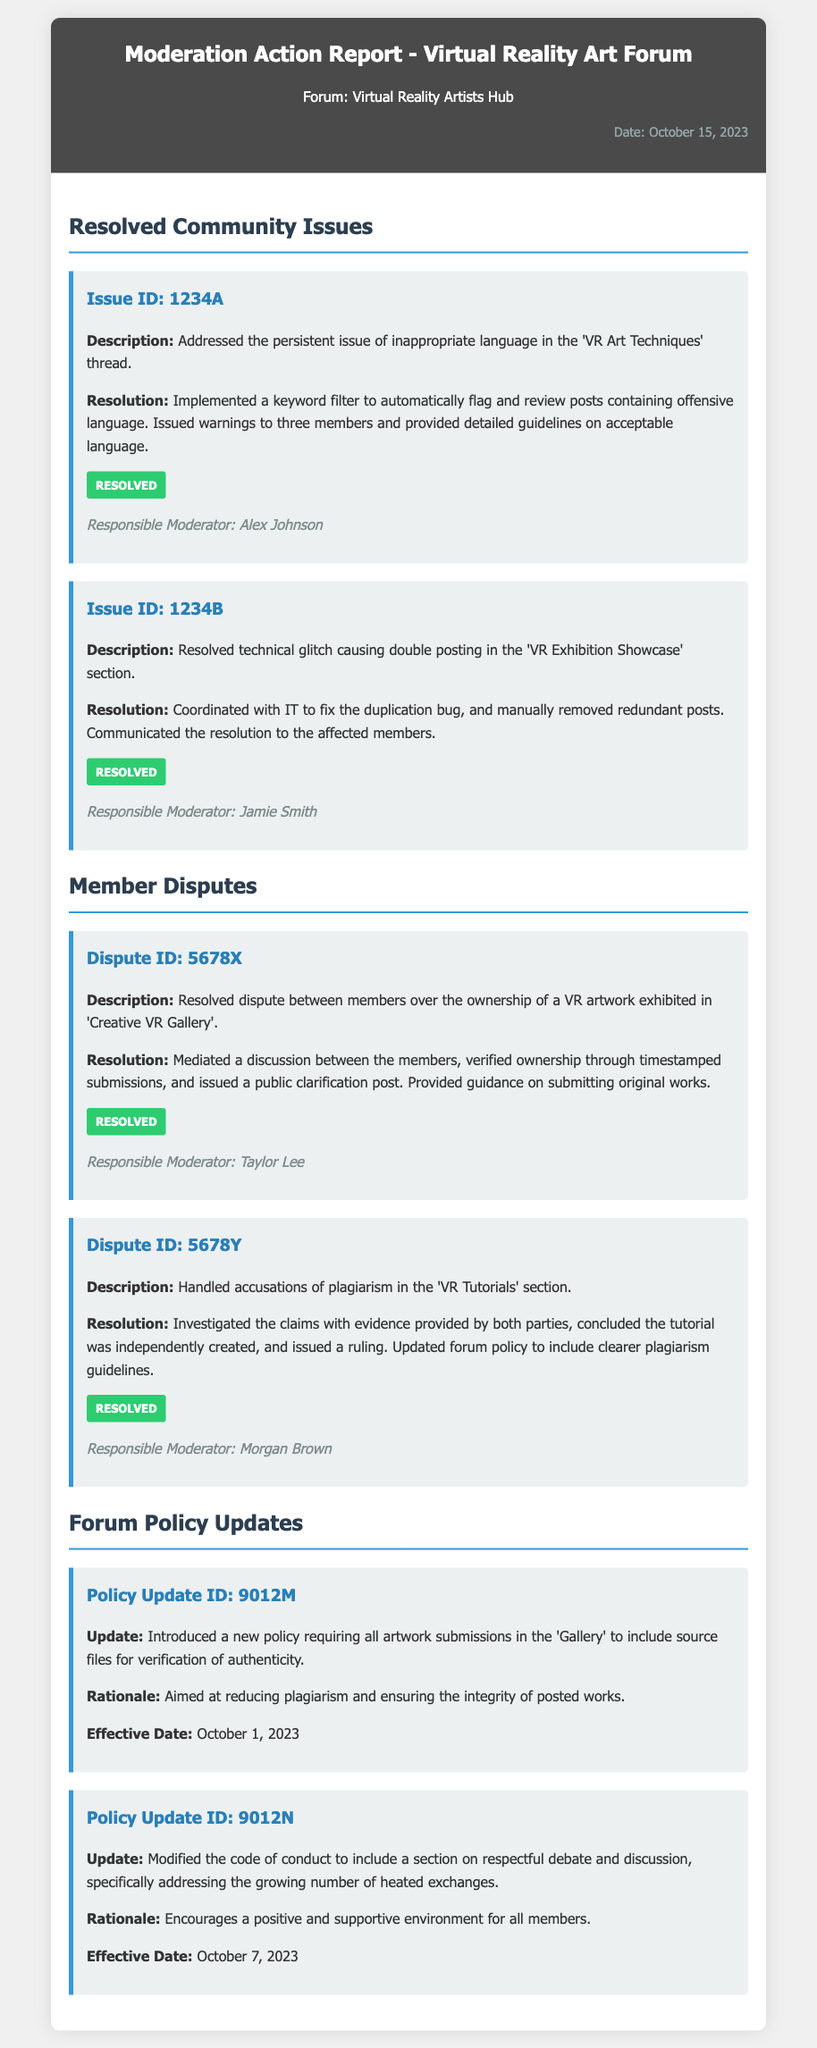What is the date of the report? The date of the report is mentioned in the header of the document.
Answer: October 15, 2023 Who is the responsible moderator for Issue ID: 1234A? The responsible moderator for each issue is listed within the issue's details.
Answer: Alex Johnson What is the main resolution for the dispute ID: 5678Y? The main resolution involves investigating claims and concludes the tutorial was independently created while updating forum policy.
Answer: Investigated claims What is the effective date of the policy update regarding artwork submissions? The effective dates for policy updates are specified separately within each update's details.
Answer: October 1, 2023 How many issues are reported as resolved in the document? The number of resolved issues is determined by counting each issue listed under "Resolved Community Issues".
Answer: 2 What new policy was introduced regarding artwork submissions? The update on artwork submissions is clearly stated in the policy update section of the document.
Answer: Includes source files Who mediated the dispute over ownership of a VR artwork? The statement mentions the responsible moderator for each dispute.
Answer: Taylor Lee What is the rationale for modifying the code of conduct? The rationale is provided directly under the policy update regarding the code of conduct.
Answer: Encourages a positive and supportive environment What type of dispute was reported under ID: 5678X? The issue types are clearly defined in the dispute description.
Answer: Ownership of a VR artwork 